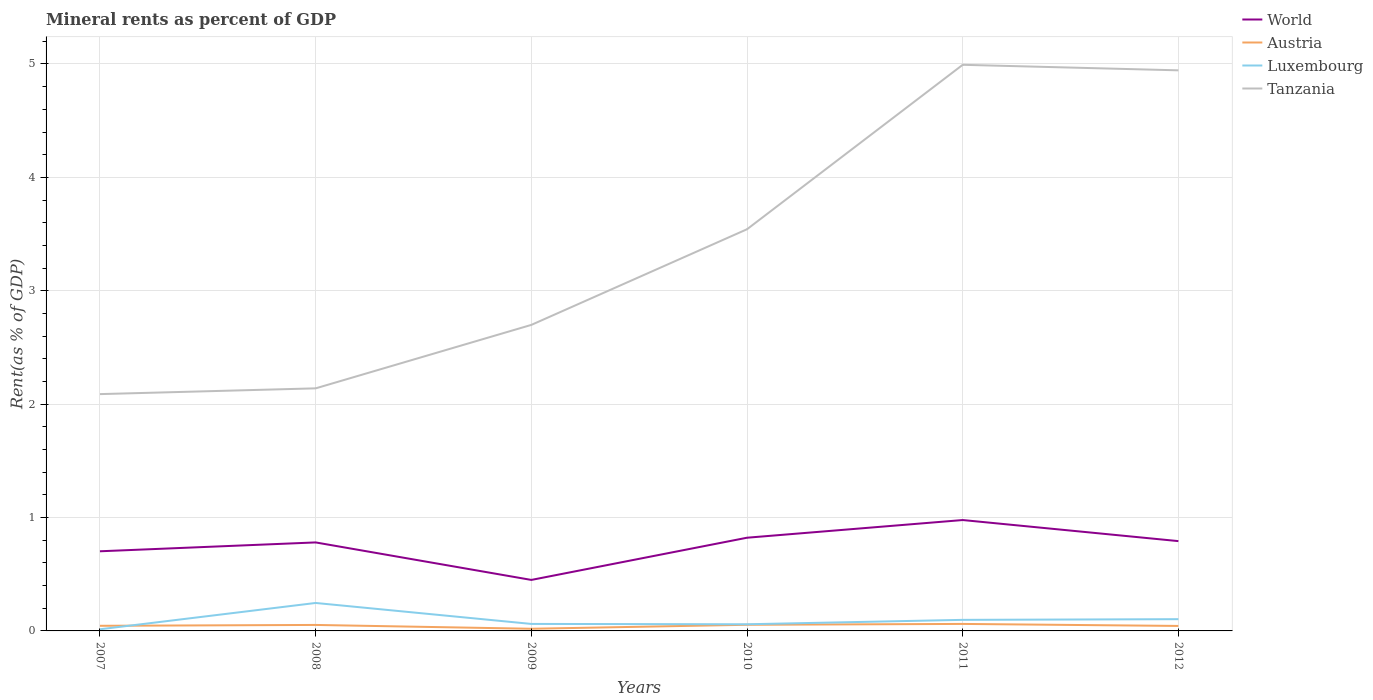Does the line corresponding to Luxembourg intersect with the line corresponding to Austria?
Keep it short and to the point. Yes. Is the number of lines equal to the number of legend labels?
Make the answer very short. Yes. Across all years, what is the maximum mineral rent in Tanzania?
Ensure brevity in your answer.  2.09. What is the total mineral rent in Tanzania in the graph?
Make the answer very short. -1.45. What is the difference between the highest and the second highest mineral rent in Luxembourg?
Your response must be concise. 0.23. Is the mineral rent in Austria strictly greater than the mineral rent in Tanzania over the years?
Offer a very short reply. Yes. Are the values on the major ticks of Y-axis written in scientific E-notation?
Ensure brevity in your answer.  No. How many legend labels are there?
Keep it short and to the point. 4. What is the title of the graph?
Provide a short and direct response. Mineral rents as percent of GDP. What is the label or title of the Y-axis?
Your answer should be very brief. Rent(as % of GDP). What is the Rent(as % of GDP) in World in 2007?
Give a very brief answer. 0.7. What is the Rent(as % of GDP) in Austria in 2007?
Your answer should be very brief. 0.05. What is the Rent(as % of GDP) of Luxembourg in 2007?
Give a very brief answer. 0.01. What is the Rent(as % of GDP) of Tanzania in 2007?
Provide a short and direct response. 2.09. What is the Rent(as % of GDP) in World in 2008?
Your response must be concise. 0.78. What is the Rent(as % of GDP) in Austria in 2008?
Offer a very short reply. 0.05. What is the Rent(as % of GDP) in Luxembourg in 2008?
Keep it short and to the point. 0.25. What is the Rent(as % of GDP) of Tanzania in 2008?
Ensure brevity in your answer.  2.14. What is the Rent(as % of GDP) of World in 2009?
Provide a short and direct response. 0.45. What is the Rent(as % of GDP) in Austria in 2009?
Provide a succinct answer. 0.02. What is the Rent(as % of GDP) of Luxembourg in 2009?
Offer a very short reply. 0.06. What is the Rent(as % of GDP) in Tanzania in 2009?
Your answer should be very brief. 2.7. What is the Rent(as % of GDP) in World in 2010?
Provide a succinct answer. 0.82. What is the Rent(as % of GDP) in Austria in 2010?
Keep it short and to the point. 0.05. What is the Rent(as % of GDP) in Luxembourg in 2010?
Provide a succinct answer. 0.06. What is the Rent(as % of GDP) in Tanzania in 2010?
Provide a succinct answer. 3.54. What is the Rent(as % of GDP) of World in 2011?
Offer a very short reply. 0.98. What is the Rent(as % of GDP) of Austria in 2011?
Your answer should be very brief. 0.06. What is the Rent(as % of GDP) in Luxembourg in 2011?
Your answer should be compact. 0.1. What is the Rent(as % of GDP) of Tanzania in 2011?
Ensure brevity in your answer.  4.99. What is the Rent(as % of GDP) of World in 2012?
Your response must be concise. 0.79. What is the Rent(as % of GDP) in Austria in 2012?
Keep it short and to the point. 0.04. What is the Rent(as % of GDP) in Luxembourg in 2012?
Offer a terse response. 0.1. What is the Rent(as % of GDP) in Tanzania in 2012?
Your answer should be very brief. 4.94. Across all years, what is the maximum Rent(as % of GDP) in World?
Make the answer very short. 0.98. Across all years, what is the maximum Rent(as % of GDP) of Austria?
Provide a succinct answer. 0.06. Across all years, what is the maximum Rent(as % of GDP) in Luxembourg?
Your response must be concise. 0.25. Across all years, what is the maximum Rent(as % of GDP) of Tanzania?
Your answer should be very brief. 4.99. Across all years, what is the minimum Rent(as % of GDP) of World?
Your answer should be compact. 0.45. Across all years, what is the minimum Rent(as % of GDP) of Austria?
Give a very brief answer. 0.02. Across all years, what is the minimum Rent(as % of GDP) in Luxembourg?
Provide a succinct answer. 0.01. Across all years, what is the minimum Rent(as % of GDP) of Tanzania?
Offer a terse response. 2.09. What is the total Rent(as % of GDP) in World in the graph?
Offer a very short reply. 4.52. What is the total Rent(as % of GDP) in Austria in the graph?
Your answer should be very brief. 0.28. What is the total Rent(as % of GDP) of Luxembourg in the graph?
Your answer should be very brief. 0.58. What is the total Rent(as % of GDP) in Tanzania in the graph?
Make the answer very short. 20.41. What is the difference between the Rent(as % of GDP) of World in 2007 and that in 2008?
Your response must be concise. -0.08. What is the difference between the Rent(as % of GDP) of Austria in 2007 and that in 2008?
Ensure brevity in your answer.  -0.01. What is the difference between the Rent(as % of GDP) of Luxembourg in 2007 and that in 2008?
Make the answer very short. -0.23. What is the difference between the Rent(as % of GDP) in Tanzania in 2007 and that in 2008?
Offer a very short reply. -0.05. What is the difference between the Rent(as % of GDP) of World in 2007 and that in 2009?
Ensure brevity in your answer.  0.25. What is the difference between the Rent(as % of GDP) of Austria in 2007 and that in 2009?
Offer a very short reply. 0.03. What is the difference between the Rent(as % of GDP) in Luxembourg in 2007 and that in 2009?
Provide a short and direct response. -0.05. What is the difference between the Rent(as % of GDP) of Tanzania in 2007 and that in 2009?
Provide a succinct answer. -0.61. What is the difference between the Rent(as % of GDP) of World in 2007 and that in 2010?
Keep it short and to the point. -0.12. What is the difference between the Rent(as % of GDP) in Austria in 2007 and that in 2010?
Offer a terse response. -0.01. What is the difference between the Rent(as % of GDP) of Luxembourg in 2007 and that in 2010?
Your response must be concise. -0.04. What is the difference between the Rent(as % of GDP) of Tanzania in 2007 and that in 2010?
Provide a short and direct response. -1.45. What is the difference between the Rent(as % of GDP) of World in 2007 and that in 2011?
Your answer should be compact. -0.28. What is the difference between the Rent(as % of GDP) of Austria in 2007 and that in 2011?
Ensure brevity in your answer.  -0.02. What is the difference between the Rent(as % of GDP) of Luxembourg in 2007 and that in 2011?
Offer a very short reply. -0.08. What is the difference between the Rent(as % of GDP) in Tanzania in 2007 and that in 2011?
Provide a short and direct response. -2.9. What is the difference between the Rent(as % of GDP) in World in 2007 and that in 2012?
Provide a succinct answer. -0.09. What is the difference between the Rent(as % of GDP) of Austria in 2007 and that in 2012?
Make the answer very short. 0. What is the difference between the Rent(as % of GDP) of Luxembourg in 2007 and that in 2012?
Your response must be concise. -0.09. What is the difference between the Rent(as % of GDP) of Tanzania in 2007 and that in 2012?
Your answer should be compact. -2.86. What is the difference between the Rent(as % of GDP) of World in 2008 and that in 2009?
Keep it short and to the point. 0.33. What is the difference between the Rent(as % of GDP) in Austria in 2008 and that in 2009?
Provide a succinct answer. 0.03. What is the difference between the Rent(as % of GDP) of Luxembourg in 2008 and that in 2009?
Provide a succinct answer. 0.18. What is the difference between the Rent(as % of GDP) of Tanzania in 2008 and that in 2009?
Make the answer very short. -0.56. What is the difference between the Rent(as % of GDP) in World in 2008 and that in 2010?
Offer a very short reply. -0.04. What is the difference between the Rent(as % of GDP) of Austria in 2008 and that in 2010?
Make the answer very short. -0. What is the difference between the Rent(as % of GDP) of Luxembourg in 2008 and that in 2010?
Ensure brevity in your answer.  0.19. What is the difference between the Rent(as % of GDP) in Tanzania in 2008 and that in 2010?
Offer a terse response. -1.4. What is the difference between the Rent(as % of GDP) in World in 2008 and that in 2011?
Ensure brevity in your answer.  -0.2. What is the difference between the Rent(as % of GDP) in Austria in 2008 and that in 2011?
Ensure brevity in your answer.  -0.01. What is the difference between the Rent(as % of GDP) of Luxembourg in 2008 and that in 2011?
Provide a short and direct response. 0.15. What is the difference between the Rent(as % of GDP) of Tanzania in 2008 and that in 2011?
Your answer should be very brief. -2.85. What is the difference between the Rent(as % of GDP) of World in 2008 and that in 2012?
Your response must be concise. -0.01. What is the difference between the Rent(as % of GDP) of Austria in 2008 and that in 2012?
Provide a succinct answer. 0.01. What is the difference between the Rent(as % of GDP) of Luxembourg in 2008 and that in 2012?
Your response must be concise. 0.14. What is the difference between the Rent(as % of GDP) in Tanzania in 2008 and that in 2012?
Your answer should be very brief. -2.8. What is the difference between the Rent(as % of GDP) of World in 2009 and that in 2010?
Make the answer very short. -0.37. What is the difference between the Rent(as % of GDP) of Austria in 2009 and that in 2010?
Provide a short and direct response. -0.04. What is the difference between the Rent(as % of GDP) of Luxembourg in 2009 and that in 2010?
Keep it short and to the point. 0. What is the difference between the Rent(as % of GDP) of Tanzania in 2009 and that in 2010?
Keep it short and to the point. -0.84. What is the difference between the Rent(as % of GDP) of World in 2009 and that in 2011?
Your answer should be very brief. -0.53. What is the difference between the Rent(as % of GDP) of Austria in 2009 and that in 2011?
Your response must be concise. -0.04. What is the difference between the Rent(as % of GDP) in Luxembourg in 2009 and that in 2011?
Offer a terse response. -0.04. What is the difference between the Rent(as % of GDP) of Tanzania in 2009 and that in 2011?
Your answer should be very brief. -2.29. What is the difference between the Rent(as % of GDP) in World in 2009 and that in 2012?
Make the answer very short. -0.34. What is the difference between the Rent(as % of GDP) of Austria in 2009 and that in 2012?
Offer a terse response. -0.02. What is the difference between the Rent(as % of GDP) of Luxembourg in 2009 and that in 2012?
Give a very brief answer. -0.04. What is the difference between the Rent(as % of GDP) in Tanzania in 2009 and that in 2012?
Offer a terse response. -2.25. What is the difference between the Rent(as % of GDP) in World in 2010 and that in 2011?
Your answer should be very brief. -0.16. What is the difference between the Rent(as % of GDP) in Austria in 2010 and that in 2011?
Keep it short and to the point. -0.01. What is the difference between the Rent(as % of GDP) in Luxembourg in 2010 and that in 2011?
Provide a short and direct response. -0.04. What is the difference between the Rent(as % of GDP) of Tanzania in 2010 and that in 2011?
Give a very brief answer. -1.45. What is the difference between the Rent(as % of GDP) in World in 2010 and that in 2012?
Offer a terse response. 0.03. What is the difference between the Rent(as % of GDP) of Austria in 2010 and that in 2012?
Make the answer very short. 0.01. What is the difference between the Rent(as % of GDP) in Luxembourg in 2010 and that in 2012?
Give a very brief answer. -0.04. What is the difference between the Rent(as % of GDP) of Tanzania in 2010 and that in 2012?
Offer a terse response. -1.4. What is the difference between the Rent(as % of GDP) of World in 2011 and that in 2012?
Ensure brevity in your answer.  0.19. What is the difference between the Rent(as % of GDP) of Austria in 2011 and that in 2012?
Offer a very short reply. 0.02. What is the difference between the Rent(as % of GDP) of Luxembourg in 2011 and that in 2012?
Ensure brevity in your answer.  -0.01. What is the difference between the Rent(as % of GDP) in Tanzania in 2011 and that in 2012?
Offer a very short reply. 0.05. What is the difference between the Rent(as % of GDP) in World in 2007 and the Rent(as % of GDP) in Austria in 2008?
Give a very brief answer. 0.65. What is the difference between the Rent(as % of GDP) in World in 2007 and the Rent(as % of GDP) in Luxembourg in 2008?
Keep it short and to the point. 0.46. What is the difference between the Rent(as % of GDP) of World in 2007 and the Rent(as % of GDP) of Tanzania in 2008?
Provide a succinct answer. -1.44. What is the difference between the Rent(as % of GDP) in Austria in 2007 and the Rent(as % of GDP) in Luxembourg in 2008?
Your answer should be compact. -0.2. What is the difference between the Rent(as % of GDP) in Austria in 2007 and the Rent(as % of GDP) in Tanzania in 2008?
Your response must be concise. -2.09. What is the difference between the Rent(as % of GDP) of Luxembourg in 2007 and the Rent(as % of GDP) of Tanzania in 2008?
Offer a terse response. -2.12. What is the difference between the Rent(as % of GDP) in World in 2007 and the Rent(as % of GDP) in Austria in 2009?
Provide a short and direct response. 0.68. What is the difference between the Rent(as % of GDP) of World in 2007 and the Rent(as % of GDP) of Luxembourg in 2009?
Offer a terse response. 0.64. What is the difference between the Rent(as % of GDP) of World in 2007 and the Rent(as % of GDP) of Tanzania in 2009?
Offer a terse response. -2. What is the difference between the Rent(as % of GDP) in Austria in 2007 and the Rent(as % of GDP) in Luxembourg in 2009?
Your response must be concise. -0.02. What is the difference between the Rent(as % of GDP) in Austria in 2007 and the Rent(as % of GDP) in Tanzania in 2009?
Make the answer very short. -2.65. What is the difference between the Rent(as % of GDP) of Luxembourg in 2007 and the Rent(as % of GDP) of Tanzania in 2009?
Provide a short and direct response. -2.68. What is the difference between the Rent(as % of GDP) of World in 2007 and the Rent(as % of GDP) of Austria in 2010?
Keep it short and to the point. 0.65. What is the difference between the Rent(as % of GDP) in World in 2007 and the Rent(as % of GDP) in Luxembourg in 2010?
Give a very brief answer. 0.64. What is the difference between the Rent(as % of GDP) of World in 2007 and the Rent(as % of GDP) of Tanzania in 2010?
Keep it short and to the point. -2.84. What is the difference between the Rent(as % of GDP) in Austria in 2007 and the Rent(as % of GDP) in Luxembourg in 2010?
Your answer should be very brief. -0.01. What is the difference between the Rent(as % of GDP) in Austria in 2007 and the Rent(as % of GDP) in Tanzania in 2010?
Your answer should be compact. -3.5. What is the difference between the Rent(as % of GDP) in Luxembourg in 2007 and the Rent(as % of GDP) in Tanzania in 2010?
Offer a terse response. -3.53. What is the difference between the Rent(as % of GDP) of World in 2007 and the Rent(as % of GDP) of Austria in 2011?
Ensure brevity in your answer.  0.64. What is the difference between the Rent(as % of GDP) of World in 2007 and the Rent(as % of GDP) of Luxembourg in 2011?
Your response must be concise. 0.6. What is the difference between the Rent(as % of GDP) in World in 2007 and the Rent(as % of GDP) in Tanzania in 2011?
Keep it short and to the point. -4.29. What is the difference between the Rent(as % of GDP) in Austria in 2007 and the Rent(as % of GDP) in Luxembourg in 2011?
Offer a terse response. -0.05. What is the difference between the Rent(as % of GDP) of Austria in 2007 and the Rent(as % of GDP) of Tanzania in 2011?
Your answer should be compact. -4.95. What is the difference between the Rent(as % of GDP) of Luxembourg in 2007 and the Rent(as % of GDP) of Tanzania in 2011?
Keep it short and to the point. -4.98. What is the difference between the Rent(as % of GDP) of World in 2007 and the Rent(as % of GDP) of Austria in 2012?
Your response must be concise. 0.66. What is the difference between the Rent(as % of GDP) in World in 2007 and the Rent(as % of GDP) in Luxembourg in 2012?
Your answer should be very brief. 0.6. What is the difference between the Rent(as % of GDP) of World in 2007 and the Rent(as % of GDP) of Tanzania in 2012?
Ensure brevity in your answer.  -4.24. What is the difference between the Rent(as % of GDP) in Austria in 2007 and the Rent(as % of GDP) in Luxembourg in 2012?
Keep it short and to the point. -0.06. What is the difference between the Rent(as % of GDP) of Austria in 2007 and the Rent(as % of GDP) of Tanzania in 2012?
Provide a short and direct response. -4.9. What is the difference between the Rent(as % of GDP) in Luxembourg in 2007 and the Rent(as % of GDP) in Tanzania in 2012?
Your answer should be compact. -4.93. What is the difference between the Rent(as % of GDP) of World in 2008 and the Rent(as % of GDP) of Austria in 2009?
Give a very brief answer. 0.76. What is the difference between the Rent(as % of GDP) in World in 2008 and the Rent(as % of GDP) in Luxembourg in 2009?
Offer a terse response. 0.72. What is the difference between the Rent(as % of GDP) in World in 2008 and the Rent(as % of GDP) in Tanzania in 2009?
Ensure brevity in your answer.  -1.92. What is the difference between the Rent(as % of GDP) in Austria in 2008 and the Rent(as % of GDP) in Luxembourg in 2009?
Give a very brief answer. -0.01. What is the difference between the Rent(as % of GDP) of Austria in 2008 and the Rent(as % of GDP) of Tanzania in 2009?
Provide a short and direct response. -2.65. What is the difference between the Rent(as % of GDP) of Luxembourg in 2008 and the Rent(as % of GDP) of Tanzania in 2009?
Give a very brief answer. -2.45. What is the difference between the Rent(as % of GDP) in World in 2008 and the Rent(as % of GDP) in Austria in 2010?
Your response must be concise. 0.73. What is the difference between the Rent(as % of GDP) in World in 2008 and the Rent(as % of GDP) in Luxembourg in 2010?
Offer a very short reply. 0.72. What is the difference between the Rent(as % of GDP) of World in 2008 and the Rent(as % of GDP) of Tanzania in 2010?
Your response must be concise. -2.76. What is the difference between the Rent(as % of GDP) in Austria in 2008 and the Rent(as % of GDP) in Luxembourg in 2010?
Provide a succinct answer. -0.01. What is the difference between the Rent(as % of GDP) in Austria in 2008 and the Rent(as % of GDP) in Tanzania in 2010?
Your answer should be very brief. -3.49. What is the difference between the Rent(as % of GDP) of Luxembourg in 2008 and the Rent(as % of GDP) of Tanzania in 2010?
Ensure brevity in your answer.  -3.3. What is the difference between the Rent(as % of GDP) in World in 2008 and the Rent(as % of GDP) in Austria in 2011?
Offer a terse response. 0.72. What is the difference between the Rent(as % of GDP) in World in 2008 and the Rent(as % of GDP) in Luxembourg in 2011?
Make the answer very short. 0.68. What is the difference between the Rent(as % of GDP) in World in 2008 and the Rent(as % of GDP) in Tanzania in 2011?
Provide a succinct answer. -4.21. What is the difference between the Rent(as % of GDP) of Austria in 2008 and the Rent(as % of GDP) of Luxembourg in 2011?
Give a very brief answer. -0.04. What is the difference between the Rent(as % of GDP) of Austria in 2008 and the Rent(as % of GDP) of Tanzania in 2011?
Offer a terse response. -4.94. What is the difference between the Rent(as % of GDP) in Luxembourg in 2008 and the Rent(as % of GDP) in Tanzania in 2011?
Offer a very short reply. -4.75. What is the difference between the Rent(as % of GDP) in World in 2008 and the Rent(as % of GDP) in Austria in 2012?
Offer a terse response. 0.74. What is the difference between the Rent(as % of GDP) in World in 2008 and the Rent(as % of GDP) in Luxembourg in 2012?
Make the answer very short. 0.68. What is the difference between the Rent(as % of GDP) of World in 2008 and the Rent(as % of GDP) of Tanzania in 2012?
Ensure brevity in your answer.  -4.16. What is the difference between the Rent(as % of GDP) in Austria in 2008 and the Rent(as % of GDP) in Luxembourg in 2012?
Make the answer very short. -0.05. What is the difference between the Rent(as % of GDP) in Austria in 2008 and the Rent(as % of GDP) in Tanzania in 2012?
Provide a short and direct response. -4.89. What is the difference between the Rent(as % of GDP) of Luxembourg in 2008 and the Rent(as % of GDP) of Tanzania in 2012?
Make the answer very short. -4.7. What is the difference between the Rent(as % of GDP) in World in 2009 and the Rent(as % of GDP) in Austria in 2010?
Your answer should be compact. 0.4. What is the difference between the Rent(as % of GDP) in World in 2009 and the Rent(as % of GDP) in Luxembourg in 2010?
Offer a very short reply. 0.39. What is the difference between the Rent(as % of GDP) in World in 2009 and the Rent(as % of GDP) in Tanzania in 2010?
Your answer should be compact. -3.09. What is the difference between the Rent(as % of GDP) of Austria in 2009 and the Rent(as % of GDP) of Luxembourg in 2010?
Your answer should be compact. -0.04. What is the difference between the Rent(as % of GDP) of Austria in 2009 and the Rent(as % of GDP) of Tanzania in 2010?
Provide a succinct answer. -3.52. What is the difference between the Rent(as % of GDP) of Luxembourg in 2009 and the Rent(as % of GDP) of Tanzania in 2010?
Provide a short and direct response. -3.48. What is the difference between the Rent(as % of GDP) of World in 2009 and the Rent(as % of GDP) of Austria in 2011?
Keep it short and to the point. 0.39. What is the difference between the Rent(as % of GDP) of World in 2009 and the Rent(as % of GDP) of Luxembourg in 2011?
Provide a succinct answer. 0.35. What is the difference between the Rent(as % of GDP) in World in 2009 and the Rent(as % of GDP) in Tanzania in 2011?
Provide a succinct answer. -4.54. What is the difference between the Rent(as % of GDP) in Austria in 2009 and the Rent(as % of GDP) in Luxembourg in 2011?
Ensure brevity in your answer.  -0.08. What is the difference between the Rent(as % of GDP) in Austria in 2009 and the Rent(as % of GDP) in Tanzania in 2011?
Ensure brevity in your answer.  -4.97. What is the difference between the Rent(as % of GDP) of Luxembourg in 2009 and the Rent(as % of GDP) of Tanzania in 2011?
Provide a short and direct response. -4.93. What is the difference between the Rent(as % of GDP) in World in 2009 and the Rent(as % of GDP) in Austria in 2012?
Make the answer very short. 0.41. What is the difference between the Rent(as % of GDP) of World in 2009 and the Rent(as % of GDP) of Luxembourg in 2012?
Provide a succinct answer. 0.35. What is the difference between the Rent(as % of GDP) in World in 2009 and the Rent(as % of GDP) in Tanzania in 2012?
Provide a short and direct response. -4.49. What is the difference between the Rent(as % of GDP) in Austria in 2009 and the Rent(as % of GDP) in Luxembourg in 2012?
Keep it short and to the point. -0.08. What is the difference between the Rent(as % of GDP) of Austria in 2009 and the Rent(as % of GDP) of Tanzania in 2012?
Your answer should be compact. -4.92. What is the difference between the Rent(as % of GDP) of Luxembourg in 2009 and the Rent(as % of GDP) of Tanzania in 2012?
Provide a succinct answer. -4.88. What is the difference between the Rent(as % of GDP) in World in 2010 and the Rent(as % of GDP) in Austria in 2011?
Provide a short and direct response. 0.76. What is the difference between the Rent(as % of GDP) of World in 2010 and the Rent(as % of GDP) of Luxembourg in 2011?
Make the answer very short. 0.72. What is the difference between the Rent(as % of GDP) in World in 2010 and the Rent(as % of GDP) in Tanzania in 2011?
Offer a very short reply. -4.17. What is the difference between the Rent(as % of GDP) in Austria in 2010 and the Rent(as % of GDP) in Luxembourg in 2011?
Offer a very short reply. -0.04. What is the difference between the Rent(as % of GDP) of Austria in 2010 and the Rent(as % of GDP) of Tanzania in 2011?
Your answer should be very brief. -4.94. What is the difference between the Rent(as % of GDP) in Luxembourg in 2010 and the Rent(as % of GDP) in Tanzania in 2011?
Offer a terse response. -4.93. What is the difference between the Rent(as % of GDP) of World in 2010 and the Rent(as % of GDP) of Austria in 2012?
Ensure brevity in your answer.  0.78. What is the difference between the Rent(as % of GDP) in World in 2010 and the Rent(as % of GDP) in Luxembourg in 2012?
Keep it short and to the point. 0.72. What is the difference between the Rent(as % of GDP) of World in 2010 and the Rent(as % of GDP) of Tanzania in 2012?
Provide a short and direct response. -4.12. What is the difference between the Rent(as % of GDP) of Austria in 2010 and the Rent(as % of GDP) of Luxembourg in 2012?
Offer a terse response. -0.05. What is the difference between the Rent(as % of GDP) in Austria in 2010 and the Rent(as % of GDP) in Tanzania in 2012?
Provide a succinct answer. -4.89. What is the difference between the Rent(as % of GDP) of Luxembourg in 2010 and the Rent(as % of GDP) of Tanzania in 2012?
Give a very brief answer. -4.89. What is the difference between the Rent(as % of GDP) of World in 2011 and the Rent(as % of GDP) of Austria in 2012?
Your response must be concise. 0.93. What is the difference between the Rent(as % of GDP) in World in 2011 and the Rent(as % of GDP) in Luxembourg in 2012?
Make the answer very short. 0.87. What is the difference between the Rent(as % of GDP) in World in 2011 and the Rent(as % of GDP) in Tanzania in 2012?
Provide a succinct answer. -3.97. What is the difference between the Rent(as % of GDP) in Austria in 2011 and the Rent(as % of GDP) in Luxembourg in 2012?
Make the answer very short. -0.04. What is the difference between the Rent(as % of GDP) of Austria in 2011 and the Rent(as % of GDP) of Tanzania in 2012?
Give a very brief answer. -4.88. What is the difference between the Rent(as % of GDP) of Luxembourg in 2011 and the Rent(as % of GDP) of Tanzania in 2012?
Provide a short and direct response. -4.85. What is the average Rent(as % of GDP) in World per year?
Keep it short and to the point. 0.75. What is the average Rent(as % of GDP) in Austria per year?
Keep it short and to the point. 0.05. What is the average Rent(as % of GDP) of Luxembourg per year?
Your response must be concise. 0.1. What is the average Rent(as % of GDP) in Tanzania per year?
Give a very brief answer. 3.4. In the year 2007, what is the difference between the Rent(as % of GDP) in World and Rent(as % of GDP) in Austria?
Provide a succinct answer. 0.66. In the year 2007, what is the difference between the Rent(as % of GDP) of World and Rent(as % of GDP) of Luxembourg?
Offer a very short reply. 0.69. In the year 2007, what is the difference between the Rent(as % of GDP) in World and Rent(as % of GDP) in Tanzania?
Your response must be concise. -1.39. In the year 2007, what is the difference between the Rent(as % of GDP) in Austria and Rent(as % of GDP) in Luxembourg?
Offer a very short reply. 0.03. In the year 2007, what is the difference between the Rent(as % of GDP) of Austria and Rent(as % of GDP) of Tanzania?
Your answer should be very brief. -2.04. In the year 2007, what is the difference between the Rent(as % of GDP) of Luxembourg and Rent(as % of GDP) of Tanzania?
Offer a very short reply. -2.07. In the year 2008, what is the difference between the Rent(as % of GDP) of World and Rent(as % of GDP) of Austria?
Provide a short and direct response. 0.73. In the year 2008, what is the difference between the Rent(as % of GDP) in World and Rent(as % of GDP) in Luxembourg?
Your response must be concise. 0.53. In the year 2008, what is the difference between the Rent(as % of GDP) of World and Rent(as % of GDP) of Tanzania?
Your response must be concise. -1.36. In the year 2008, what is the difference between the Rent(as % of GDP) in Austria and Rent(as % of GDP) in Luxembourg?
Make the answer very short. -0.19. In the year 2008, what is the difference between the Rent(as % of GDP) of Austria and Rent(as % of GDP) of Tanzania?
Offer a very short reply. -2.09. In the year 2008, what is the difference between the Rent(as % of GDP) of Luxembourg and Rent(as % of GDP) of Tanzania?
Your answer should be compact. -1.89. In the year 2009, what is the difference between the Rent(as % of GDP) in World and Rent(as % of GDP) in Austria?
Your answer should be compact. 0.43. In the year 2009, what is the difference between the Rent(as % of GDP) of World and Rent(as % of GDP) of Luxembourg?
Your answer should be very brief. 0.39. In the year 2009, what is the difference between the Rent(as % of GDP) of World and Rent(as % of GDP) of Tanzania?
Offer a very short reply. -2.25. In the year 2009, what is the difference between the Rent(as % of GDP) in Austria and Rent(as % of GDP) in Luxembourg?
Your answer should be very brief. -0.04. In the year 2009, what is the difference between the Rent(as % of GDP) in Austria and Rent(as % of GDP) in Tanzania?
Your response must be concise. -2.68. In the year 2009, what is the difference between the Rent(as % of GDP) of Luxembourg and Rent(as % of GDP) of Tanzania?
Your answer should be compact. -2.64. In the year 2010, what is the difference between the Rent(as % of GDP) of World and Rent(as % of GDP) of Austria?
Your answer should be compact. 0.77. In the year 2010, what is the difference between the Rent(as % of GDP) of World and Rent(as % of GDP) of Luxembourg?
Your answer should be compact. 0.76. In the year 2010, what is the difference between the Rent(as % of GDP) in World and Rent(as % of GDP) in Tanzania?
Provide a short and direct response. -2.72. In the year 2010, what is the difference between the Rent(as % of GDP) in Austria and Rent(as % of GDP) in Luxembourg?
Give a very brief answer. -0. In the year 2010, what is the difference between the Rent(as % of GDP) of Austria and Rent(as % of GDP) of Tanzania?
Ensure brevity in your answer.  -3.49. In the year 2010, what is the difference between the Rent(as % of GDP) in Luxembourg and Rent(as % of GDP) in Tanzania?
Offer a terse response. -3.48. In the year 2011, what is the difference between the Rent(as % of GDP) of World and Rent(as % of GDP) of Austria?
Give a very brief answer. 0.92. In the year 2011, what is the difference between the Rent(as % of GDP) in World and Rent(as % of GDP) in Luxembourg?
Provide a succinct answer. 0.88. In the year 2011, what is the difference between the Rent(as % of GDP) of World and Rent(as % of GDP) of Tanzania?
Keep it short and to the point. -4.01. In the year 2011, what is the difference between the Rent(as % of GDP) of Austria and Rent(as % of GDP) of Luxembourg?
Provide a succinct answer. -0.04. In the year 2011, what is the difference between the Rent(as % of GDP) of Austria and Rent(as % of GDP) of Tanzania?
Your answer should be compact. -4.93. In the year 2011, what is the difference between the Rent(as % of GDP) in Luxembourg and Rent(as % of GDP) in Tanzania?
Your answer should be compact. -4.9. In the year 2012, what is the difference between the Rent(as % of GDP) in World and Rent(as % of GDP) in Austria?
Make the answer very short. 0.75. In the year 2012, what is the difference between the Rent(as % of GDP) of World and Rent(as % of GDP) of Luxembourg?
Provide a succinct answer. 0.69. In the year 2012, what is the difference between the Rent(as % of GDP) in World and Rent(as % of GDP) in Tanzania?
Keep it short and to the point. -4.15. In the year 2012, what is the difference between the Rent(as % of GDP) of Austria and Rent(as % of GDP) of Luxembourg?
Provide a short and direct response. -0.06. In the year 2012, what is the difference between the Rent(as % of GDP) of Austria and Rent(as % of GDP) of Tanzania?
Provide a short and direct response. -4.9. In the year 2012, what is the difference between the Rent(as % of GDP) of Luxembourg and Rent(as % of GDP) of Tanzania?
Your answer should be compact. -4.84. What is the ratio of the Rent(as % of GDP) of World in 2007 to that in 2008?
Your response must be concise. 0.9. What is the ratio of the Rent(as % of GDP) in Austria in 2007 to that in 2008?
Offer a very short reply. 0.86. What is the ratio of the Rent(as % of GDP) in Luxembourg in 2007 to that in 2008?
Provide a short and direct response. 0.06. What is the ratio of the Rent(as % of GDP) of Tanzania in 2007 to that in 2008?
Offer a very short reply. 0.98. What is the ratio of the Rent(as % of GDP) of World in 2007 to that in 2009?
Your response must be concise. 1.56. What is the ratio of the Rent(as % of GDP) in Austria in 2007 to that in 2009?
Your answer should be compact. 2.38. What is the ratio of the Rent(as % of GDP) of Luxembourg in 2007 to that in 2009?
Provide a succinct answer. 0.23. What is the ratio of the Rent(as % of GDP) in Tanzania in 2007 to that in 2009?
Provide a succinct answer. 0.77. What is the ratio of the Rent(as % of GDP) of World in 2007 to that in 2010?
Provide a short and direct response. 0.85. What is the ratio of the Rent(as % of GDP) in Austria in 2007 to that in 2010?
Provide a succinct answer. 0.83. What is the ratio of the Rent(as % of GDP) in Luxembourg in 2007 to that in 2010?
Give a very brief answer. 0.25. What is the ratio of the Rent(as % of GDP) of Tanzania in 2007 to that in 2010?
Ensure brevity in your answer.  0.59. What is the ratio of the Rent(as % of GDP) of World in 2007 to that in 2011?
Keep it short and to the point. 0.72. What is the ratio of the Rent(as % of GDP) of Austria in 2007 to that in 2011?
Provide a short and direct response. 0.73. What is the ratio of the Rent(as % of GDP) of Luxembourg in 2007 to that in 2011?
Offer a very short reply. 0.15. What is the ratio of the Rent(as % of GDP) of Tanzania in 2007 to that in 2011?
Offer a very short reply. 0.42. What is the ratio of the Rent(as % of GDP) of World in 2007 to that in 2012?
Your response must be concise. 0.89. What is the ratio of the Rent(as % of GDP) in Austria in 2007 to that in 2012?
Ensure brevity in your answer.  1.03. What is the ratio of the Rent(as % of GDP) of Luxembourg in 2007 to that in 2012?
Your answer should be compact. 0.14. What is the ratio of the Rent(as % of GDP) in Tanzania in 2007 to that in 2012?
Your answer should be very brief. 0.42. What is the ratio of the Rent(as % of GDP) of World in 2008 to that in 2009?
Your response must be concise. 1.74. What is the ratio of the Rent(as % of GDP) in Austria in 2008 to that in 2009?
Provide a succinct answer. 2.77. What is the ratio of the Rent(as % of GDP) in Luxembourg in 2008 to that in 2009?
Keep it short and to the point. 4. What is the ratio of the Rent(as % of GDP) in Tanzania in 2008 to that in 2009?
Your response must be concise. 0.79. What is the ratio of the Rent(as % of GDP) of World in 2008 to that in 2010?
Keep it short and to the point. 0.95. What is the ratio of the Rent(as % of GDP) of Austria in 2008 to that in 2010?
Ensure brevity in your answer.  0.97. What is the ratio of the Rent(as % of GDP) of Luxembourg in 2008 to that in 2010?
Offer a very short reply. 4.2. What is the ratio of the Rent(as % of GDP) in Tanzania in 2008 to that in 2010?
Ensure brevity in your answer.  0.6. What is the ratio of the Rent(as % of GDP) of World in 2008 to that in 2011?
Provide a short and direct response. 0.8. What is the ratio of the Rent(as % of GDP) of Austria in 2008 to that in 2011?
Offer a terse response. 0.85. What is the ratio of the Rent(as % of GDP) of Luxembourg in 2008 to that in 2011?
Offer a very short reply. 2.53. What is the ratio of the Rent(as % of GDP) of Tanzania in 2008 to that in 2011?
Your response must be concise. 0.43. What is the ratio of the Rent(as % of GDP) of World in 2008 to that in 2012?
Your answer should be compact. 0.99. What is the ratio of the Rent(as % of GDP) of Austria in 2008 to that in 2012?
Ensure brevity in your answer.  1.2. What is the ratio of the Rent(as % of GDP) of Luxembourg in 2008 to that in 2012?
Your answer should be compact. 2.38. What is the ratio of the Rent(as % of GDP) of Tanzania in 2008 to that in 2012?
Ensure brevity in your answer.  0.43. What is the ratio of the Rent(as % of GDP) in World in 2009 to that in 2010?
Ensure brevity in your answer.  0.55. What is the ratio of the Rent(as % of GDP) in Austria in 2009 to that in 2010?
Your answer should be very brief. 0.35. What is the ratio of the Rent(as % of GDP) in Luxembourg in 2009 to that in 2010?
Provide a succinct answer. 1.05. What is the ratio of the Rent(as % of GDP) in Tanzania in 2009 to that in 2010?
Offer a terse response. 0.76. What is the ratio of the Rent(as % of GDP) in World in 2009 to that in 2011?
Provide a short and direct response. 0.46. What is the ratio of the Rent(as % of GDP) in Austria in 2009 to that in 2011?
Your response must be concise. 0.31. What is the ratio of the Rent(as % of GDP) in Luxembourg in 2009 to that in 2011?
Make the answer very short. 0.63. What is the ratio of the Rent(as % of GDP) in Tanzania in 2009 to that in 2011?
Ensure brevity in your answer.  0.54. What is the ratio of the Rent(as % of GDP) of World in 2009 to that in 2012?
Ensure brevity in your answer.  0.57. What is the ratio of the Rent(as % of GDP) in Austria in 2009 to that in 2012?
Ensure brevity in your answer.  0.43. What is the ratio of the Rent(as % of GDP) in Luxembourg in 2009 to that in 2012?
Keep it short and to the point. 0.6. What is the ratio of the Rent(as % of GDP) of Tanzania in 2009 to that in 2012?
Your answer should be very brief. 0.55. What is the ratio of the Rent(as % of GDP) in World in 2010 to that in 2011?
Provide a succinct answer. 0.84. What is the ratio of the Rent(as % of GDP) in Austria in 2010 to that in 2011?
Your answer should be compact. 0.88. What is the ratio of the Rent(as % of GDP) of Luxembourg in 2010 to that in 2011?
Your answer should be compact. 0.6. What is the ratio of the Rent(as % of GDP) in Tanzania in 2010 to that in 2011?
Ensure brevity in your answer.  0.71. What is the ratio of the Rent(as % of GDP) in World in 2010 to that in 2012?
Ensure brevity in your answer.  1.04. What is the ratio of the Rent(as % of GDP) in Austria in 2010 to that in 2012?
Your response must be concise. 1.23. What is the ratio of the Rent(as % of GDP) of Luxembourg in 2010 to that in 2012?
Offer a terse response. 0.57. What is the ratio of the Rent(as % of GDP) of Tanzania in 2010 to that in 2012?
Offer a very short reply. 0.72. What is the ratio of the Rent(as % of GDP) of World in 2011 to that in 2012?
Your response must be concise. 1.23. What is the ratio of the Rent(as % of GDP) in Austria in 2011 to that in 2012?
Your answer should be compact. 1.41. What is the ratio of the Rent(as % of GDP) in Luxembourg in 2011 to that in 2012?
Ensure brevity in your answer.  0.94. What is the ratio of the Rent(as % of GDP) of Tanzania in 2011 to that in 2012?
Provide a succinct answer. 1.01. What is the difference between the highest and the second highest Rent(as % of GDP) in World?
Ensure brevity in your answer.  0.16. What is the difference between the highest and the second highest Rent(as % of GDP) in Austria?
Make the answer very short. 0.01. What is the difference between the highest and the second highest Rent(as % of GDP) in Luxembourg?
Provide a short and direct response. 0.14. What is the difference between the highest and the second highest Rent(as % of GDP) of Tanzania?
Your response must be concise. 0.05. What is the difference between the highest and the lowest Rent(as % of GDP) of World?
Your answer should be very brief. 0.53. What is the difference between the highest and the lowest Rent(as % of GDP) of Austria?
Your answer should be very brief. 0.04. What is the difference between the highest and the lowest Rent(as % of GDP) in Luxembourg?
Keep it short and to the point. 0.23. What is the difference between the highest and the lowest Rent(as % of GDP) in Tanzania?
Give a very brief answer. 2.9. 